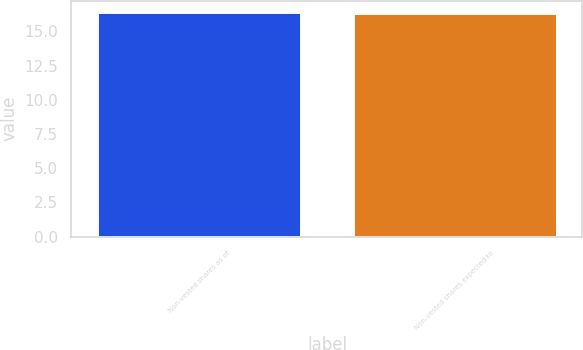Convert chart to OTSL. <chart><loc_0><loc_0><loc_500><loc_500><bar_chart><fcel>Non-vested shares as of<fcel>Non-vested shares expected to<nl><fcel>16.42<fcel>16.34<nl></chart> 